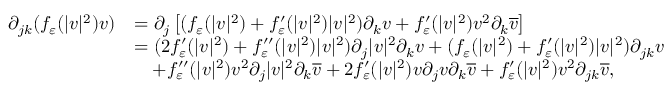<formula> <loc_0><loc_0><loc_500><loc_500>\begin{array} { r l } { \partial _ { j k } ( f _ { \varepsilon } ( | v | ^ { 2 } ) v ) } & { = \partial _ { j } \left [ ( f _ { \varepsilon } ( | v | ^ { 2 } ) + f _ { \varepsilon } ^ { \prime } ( | v | ^ { 2 } ) | v | ^ { 2 } ) \partial _ { k } v + f _ { \varepsilon } ^ { \prime } ( | v | ^ { 2 } ) v ^ { 2 } \partial _ { k } \overline { v } \right ] } \\ & { = ( 2 f _ { \varepsilon } ^ { \prime } ( | v | ^ { 2 } ) + f _ { \varepsilon } ^ { \prime \prime } ( | v | ^ { 2 } ) | v | ^ { 2 } ) \partial _ { j } | v | ^ { 2 } \partial _ { k } v + ( f _ { \varepsilon } ( | v | ^ { 2 } ) + f _ { \varepsilon } ^ { \prime } ( | v | ^ { 2 } ) | v | ^ { 2 } ) \partial _ { j k } v } \\ & { \quad + f _ { \varepsilon } ^ { \prime \prime } ( | v | ^ { 2 } ) v ^ { 2 } \partial _ { j } | v | ^ { 2 } \partial _ { k } \overline { v } + 2 f _ { \varepsilon } ^ { \prime } ( | v | ^ { 2 } ) v \partial _ { j } v \partial _ { k } \overline { v } + f _ { \varepsilon } ^ { \prime } ( | v | ^ { 2 } ) v ^ { 2 } \partial _ { j k } \overline { v } , } \end{array}</formula> 